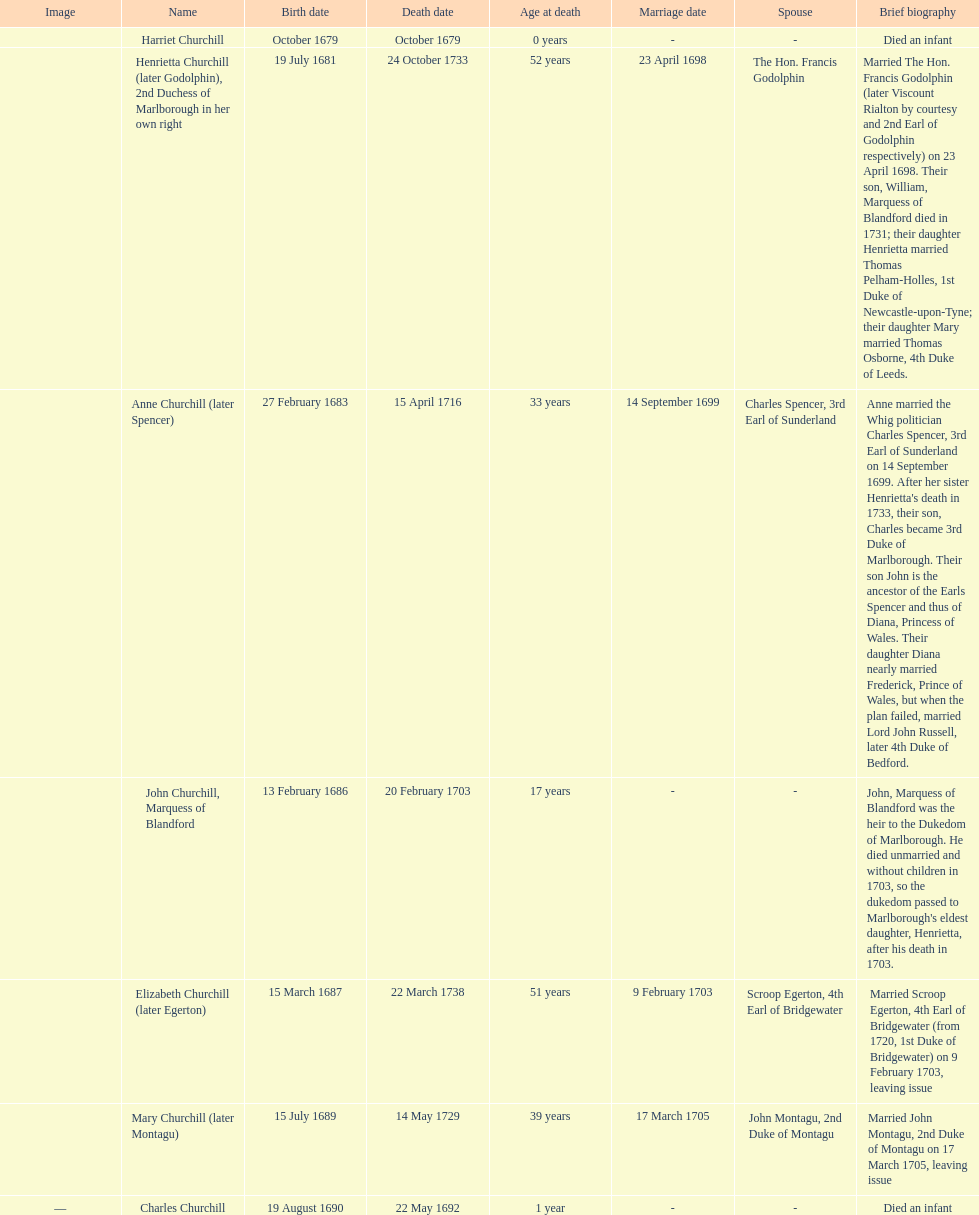Who was born before henrietta churchhill? Harriet Churchill. 